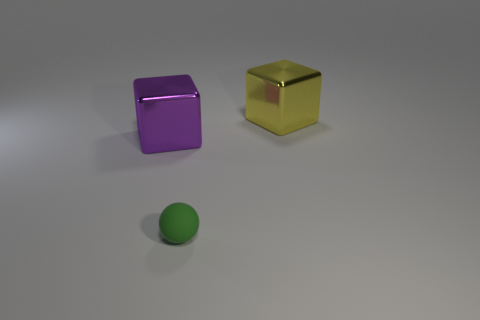Is there any other thing that has the same size as the rubber thing?
Your response must be concise. No. There is another large shiny object that is the same shape as the large yellow object; what is its color?
Offer a very short reply. Purple. Is there anything else that has the same shape as the matte thing?
Ensure brevity in your answer.  No. There is a large thing behind the metallic block on the left side of the big yellow thing; are there any green balls that are behind it?
Make the answer very short. No. What number of large purple blocks have the same material as the large yellow thing?
Keep it short and to the point. 1. There is a metal block that is on the right side of the green rubber thing; is its size the same as the metallic object that is on the left side of the big yellow metal object?
Your answer should be compact. Yes. What is the color of the big thing on the left side of the yellow object that is behind the big thing that is on the left side of the large yellow thing?
Provide a short and direct response. Purple. Is there a purple thing that has the same shape as the large yellow metallic thing?
Provide a succinct answer. Yes. Are there the same number of green rubber spheres that are behind the rubber object and big yellow objects that are in front of the yellow block?
Make the answer very short. Yes. There is a metallic object that is to the right of the purple shiny block; is it the same shape as the big purple metal object?
Provide a succinct answer. Yes. 